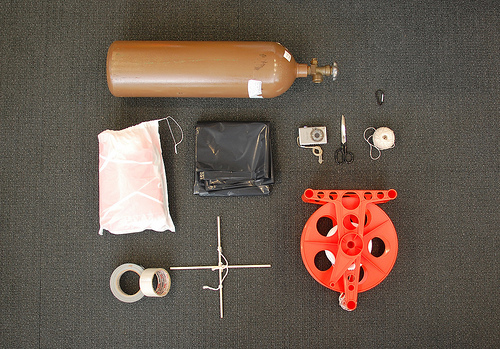<image>
Is there a gas above the bag? Yes. The gas is positioned above the bag in the vertical space, higher up in the scene. 